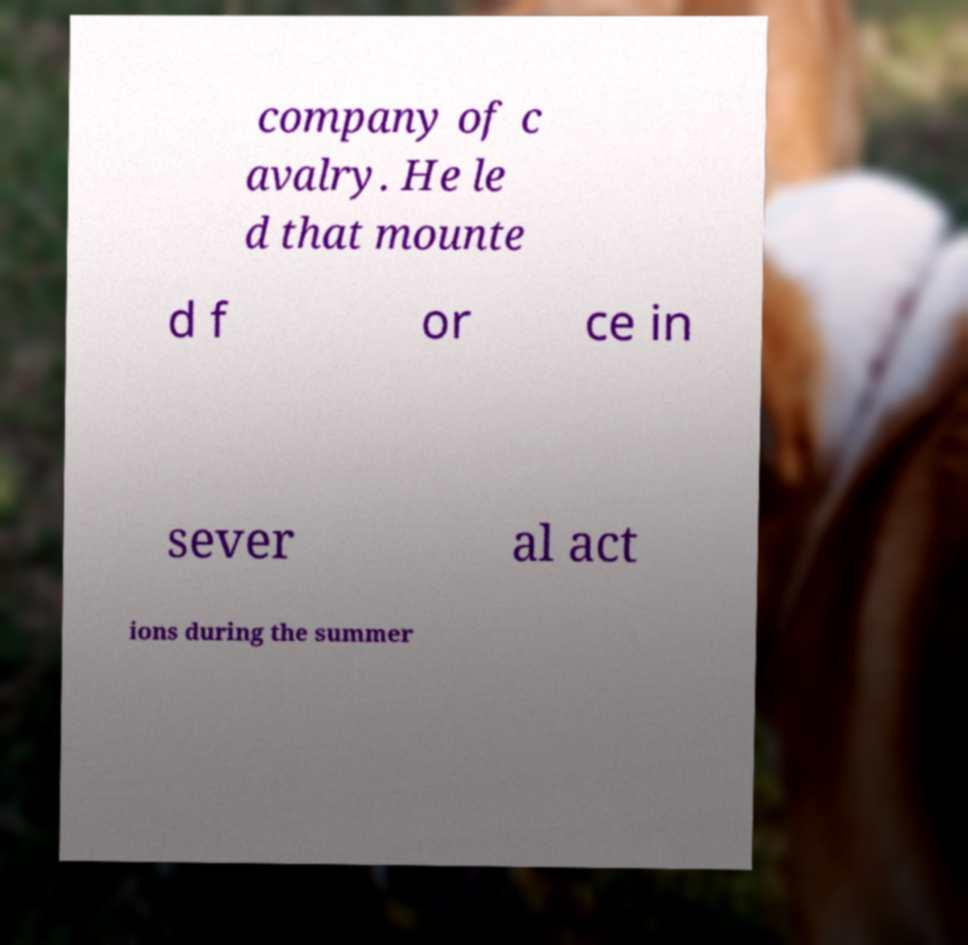Can you accurately transcribe the text from the provided image for me? company of c avalry. He le d that mounte d f or ce in sever al act ions during the summer 